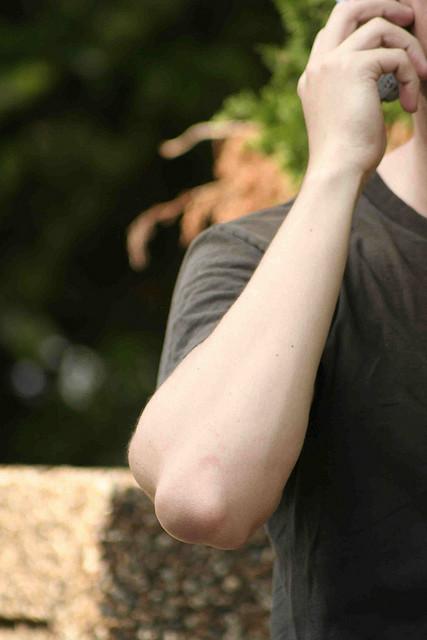What is in the person's hand?
Be succinct. Cell phone. Is the person wearing a short sleeve shirt?
Keep it brief. Yes. What elbow is visible?
Answer briefly. Right. 